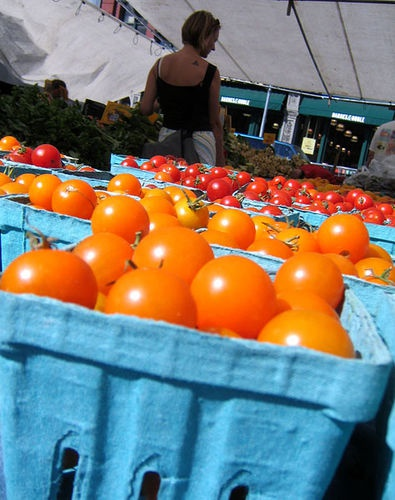Describe the objects in this image and their specific colors. I can see people in lightgray, black, maroon, gray, and darkgray tones, orange in lightgray, red, and orange tones, orange in lightgray, red, and orange tones, orange in lightgray, red, orange, and brown tones, and orange in lightgray, red, and orange tones in this image. 